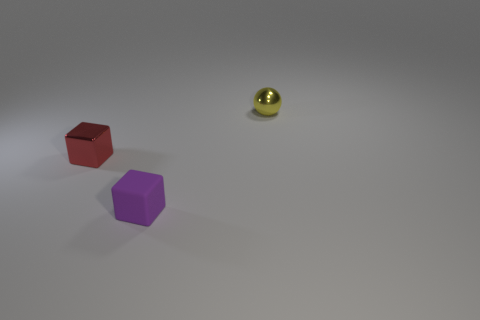Do the metal object that is on the left side of the sphere and the thing in front of the small red metallic block have the same shape?
Offer a very short reply. Yes. What color is the tiny cube that is the same material as the tiny yellow thing?
Make the answer very short. Red. The small thing that is behind the purple rubber cube and on the right side of the tiny metallic block has what shape?
Offer a terse response. Sphere. Is there a purple thing that has the same material as the ball?
Provide a short and direct response. No. Is the material of the thing that is to the left of the purple cube the same as the small object that is in front of the small red shiny block?
Your response must be concise. No. Are there more big green cylinders than balls?
Offer a terse response. No. What is the color of the cube behind the tiny purple matte cube on the right side of the small shiny object that is to the left of the tiny sphere?
Offer a very short reply. Red. There is a metallic thing that is on the left side of the yellow shiny thing; is its color the same as the tiny metallic thing that is right of the tiny metal cube?
Offer a very short reply. No. What number of purple rubber things are behind the small metal thing that is on the right side of the small purple object?
Offer a very short reply. 0. Are there any things?
Keep it short and to the point. Yes. 